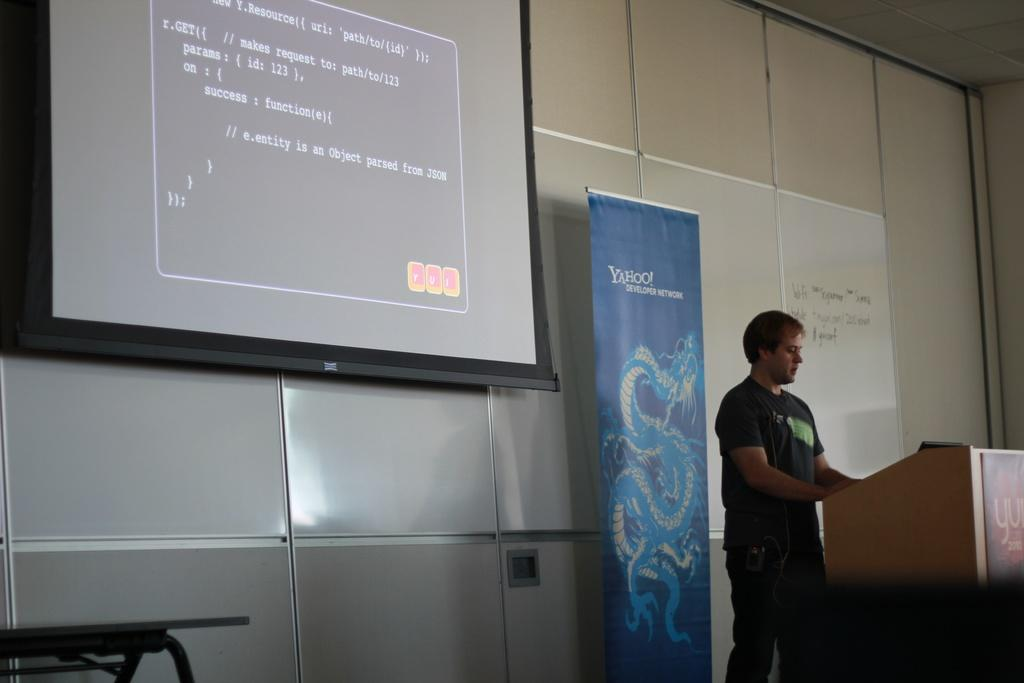<image>
Present a compact description of the photo's key features. A man standing at a poduim with a blue backdrop featuring a dragon and a yahoo logo 